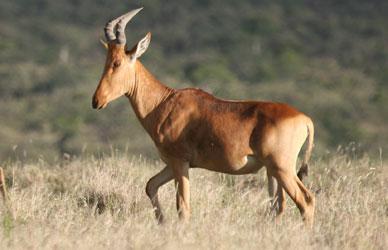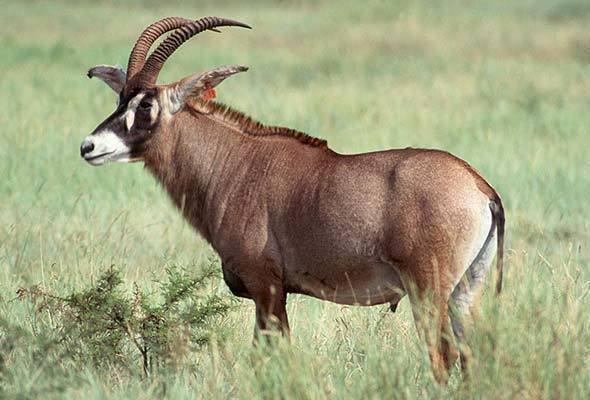The first image is the image on the left, the second image is the image on the right. Examine the images to the left and right. Is the description "One animal is heading left with their head turned and looking into the camera." accurate? Answer yes or no. No. The first image is the image on the left, the second image is the image on the right. Considering the images on both sides, is "The left and right image contains the same number of right facing antelopes." valid? Answer yes or no. Yes. 